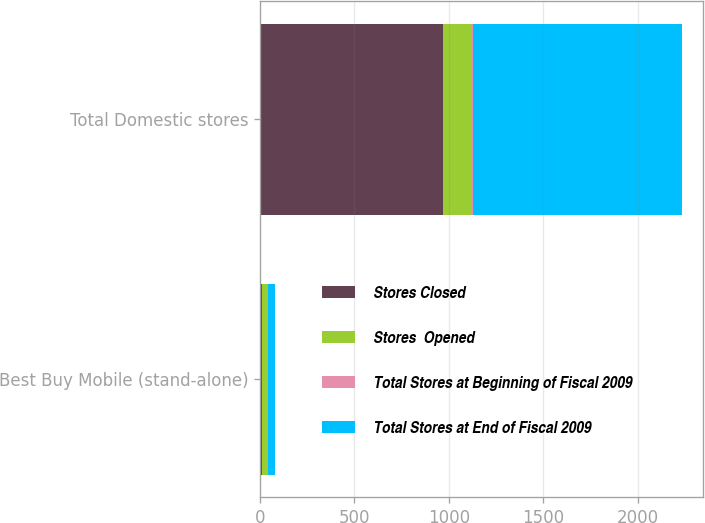Convert chart to OTSL. <chart><loc_0><loc_0><loc_500><loc_500><stacked_bar_chart><ecel><fcel>Best Buy Mobile (stand-alone)<fcel>Total Domestic stores<nl><fcel>Stores Closed<fcel>9<fcel>971<nl><fcel>Stores  Opened<fcel>32<fcel>147<nl><fcel>Total Stores at Beginning of Fiscal 2009<fcel>3<fcel>11<nl><fcel>Total Stores at End of Fiscal 2009<fcel>38<fcel>1107<nl></chart> 